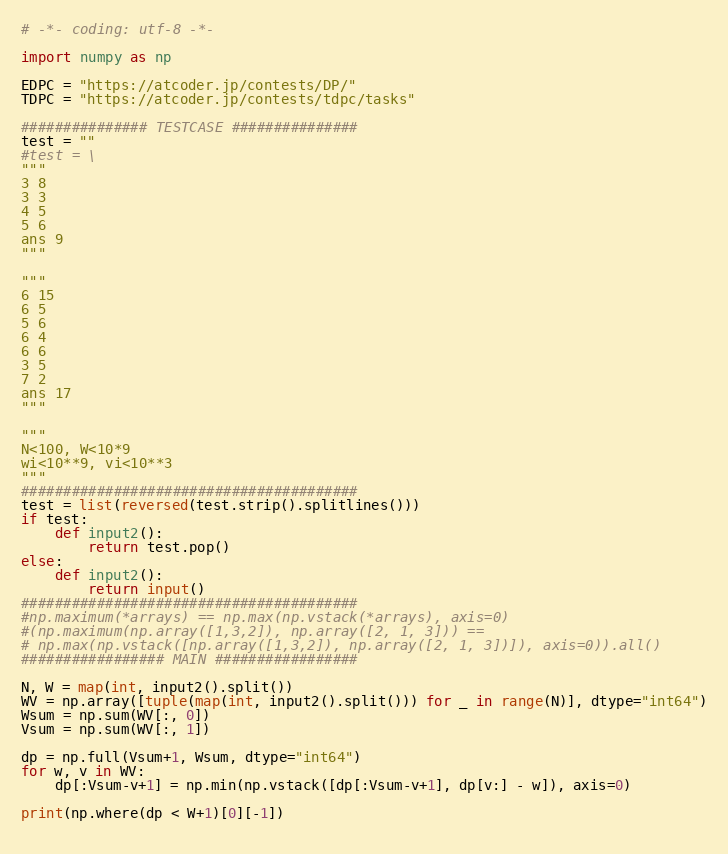Convert code to text. <code><loc_0><loc_0><loc_500><loc_500><_Python_># -*- coding: utf-8 -*-

import numpy as np

EDPC = "https://atcoder.jp/contests/DP/"
TDPC = "https://atcoder.jp/contests/tdpc/tasks"

############### TESTCASE ###############
test = ""
#test = \
"""
3 8
3 3
4 5
5 6
ans 9
"""

"""
6 15
6 5
5 6
6 4
6 6
3 5
7 2
ans 17
"""

"""
N<100, W<10*9
wi<10**9, vi<10**3 
"""
########################################
test = list(reversed(test.strip().splitlines()))
if test:
    def input2():
        return test.pop()
else:
    def input2():
        return input()
########################################
#np.maximum(*arrays) == np.max(np.vstack(*arrays), axis=0)
#(np.maximum(np.array([1,3,2]), np.array([2, 1, 3])) == 
# np.max(np.vstack([np.array([1,3,2]), np.array([2, 1, 3])]), axis=0)).all()
################# MAIN #################

N, W = map(int, input2().split())
WV = np.array([tuple(map(int, input2().split())) for _ in range(N)], dtype="int64")
Wsum = np.sum(WV[:, 0])
Vsum = np.sum(WV[:, 1])

dp = np.full(Vsum+1, Wsum, dtype="int64")
for w, v in WV:
    dp[:Vsum-v+1] = np.min(np.vstack([dp[:Vsum-v+1], dp[v:] - w]), axis=0)
    
print(np.where(dp < W+1)[0][-1])
    
</code> 